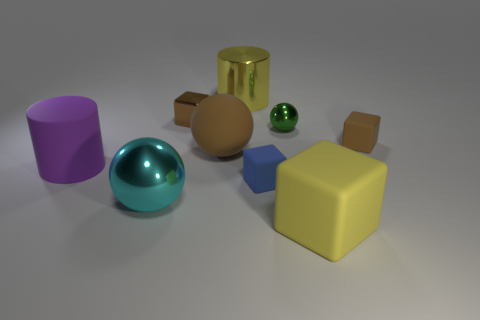What number of green things are behind the green metallic object?
Your response must be concise. 0. Is the color of the tiny metal cube the same as the large matte ball?
Offer a terse response. Yes. What number of large rubber things have the same color as the metallic cube?
Your response must be concise. 1. Are there more brown metal cubes than small brown cylinders?
Provide a short and direct response. Yes. What is the size of the block that is in front of the big brown rubber sphere and behind the big cyan thing?
Your response must be concise. Small. Do the big yellow object that is to the right of the tiny sphere and the blue object right of the cyan object have the same material?
Offer a terse response. Yes. There is a brown rubber thing that is the same size as the yellow matte object; what is its shape?
Your answer should be very brief. Sphere. Are there fewer large yellow cubes than large gray spheres?
Offer a terse response. No. There is a small shiny thing in front of the tiny brown shiny object; are there any small objects that are on the right side of it?
Offer a terse response. Yes. There is a shiny ball that is in front of the tiny blue block that is in front of the green ball; is there a green thing that is to the left of it?
Offer a very short reply. No. 